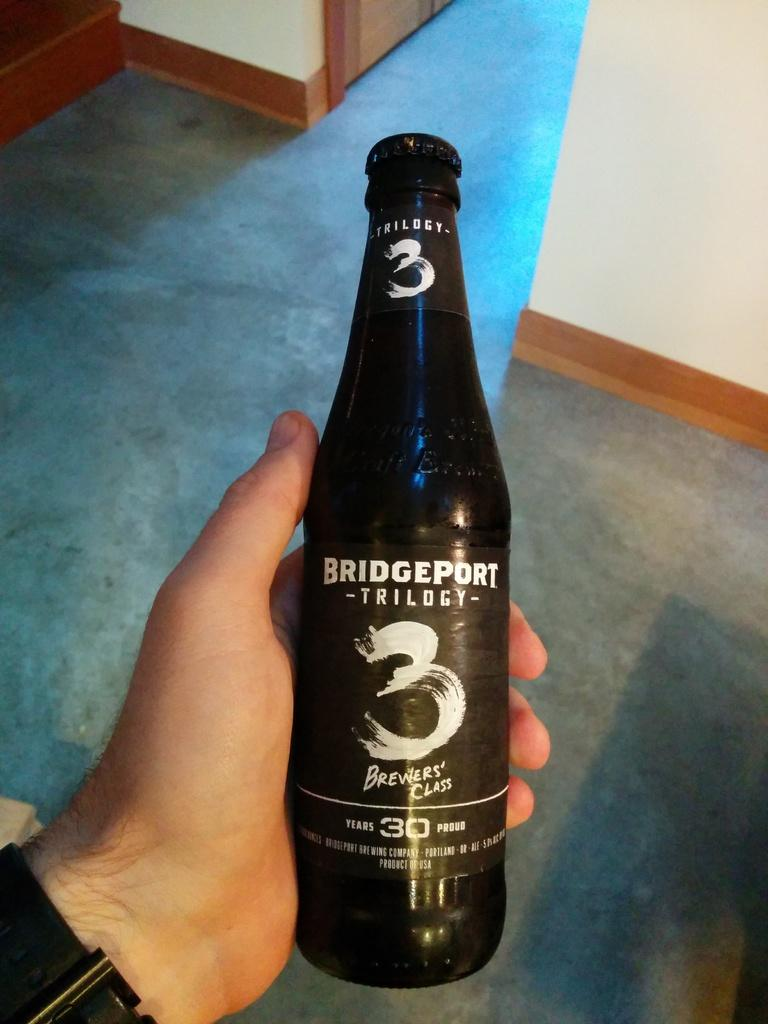<image>
Create a compact narrative representing the image presented. A beer with a BRIDGEPORT label is held in someone's hand. 